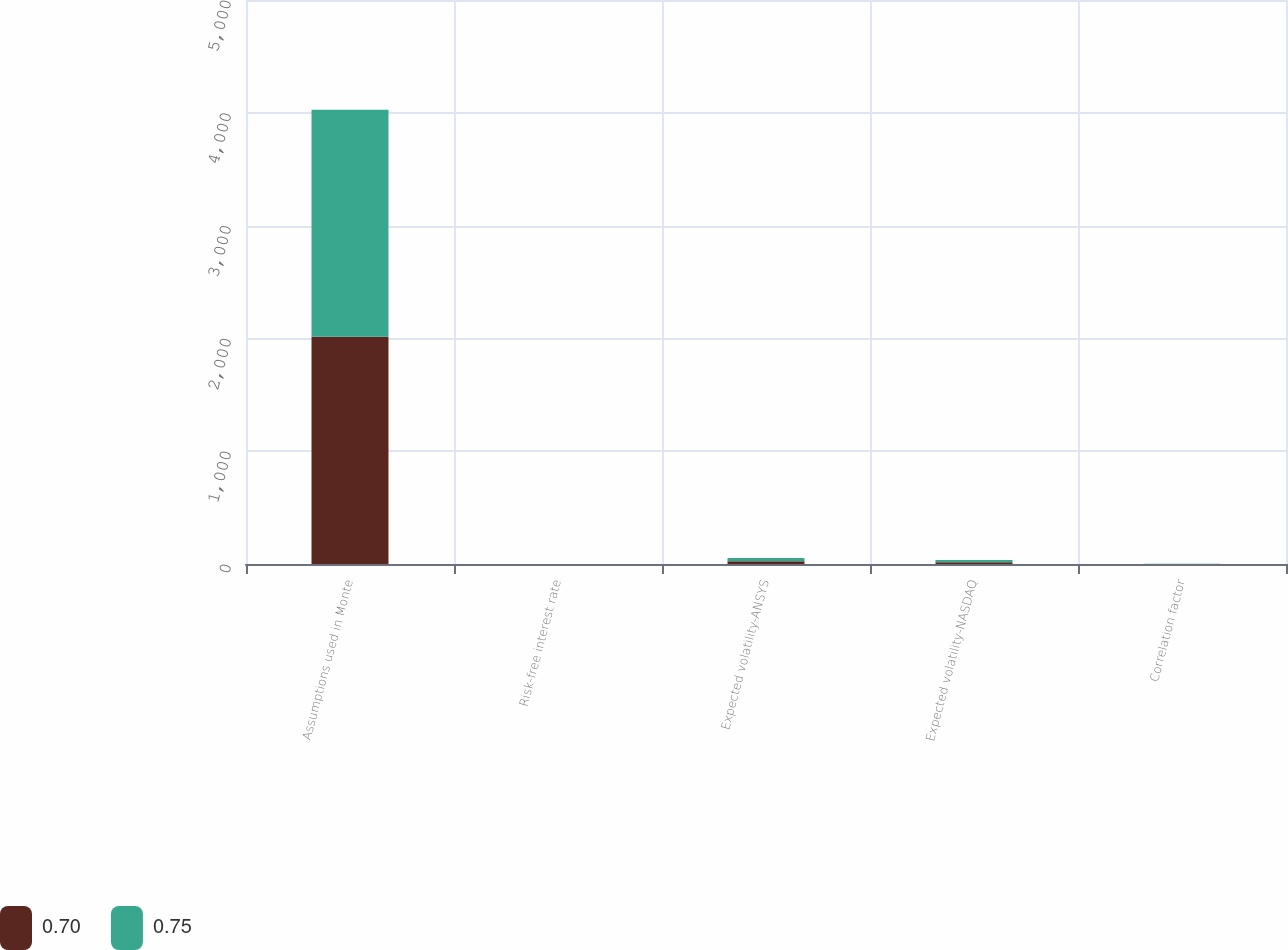<chart> <loc_0><loc_0><loc_500><loc_500><stacked_bar_chart><ecel><fcel>Assumptions used in Monte<fcel>Risk-free interest rate<fcel>Expected volatility-ANSYS<fcel>Expected volatility-NASDAQ<fcel>Correlation factor<nl><fcel>0.7<fcel>2014<fcel>0.7<fcel>25<fcel>15<fcel>0.7<nl><fcel>0.75<fcel>2012<fcel>0.16<fcel>28<fcel>20<fcel>0.75<nl></chart> 